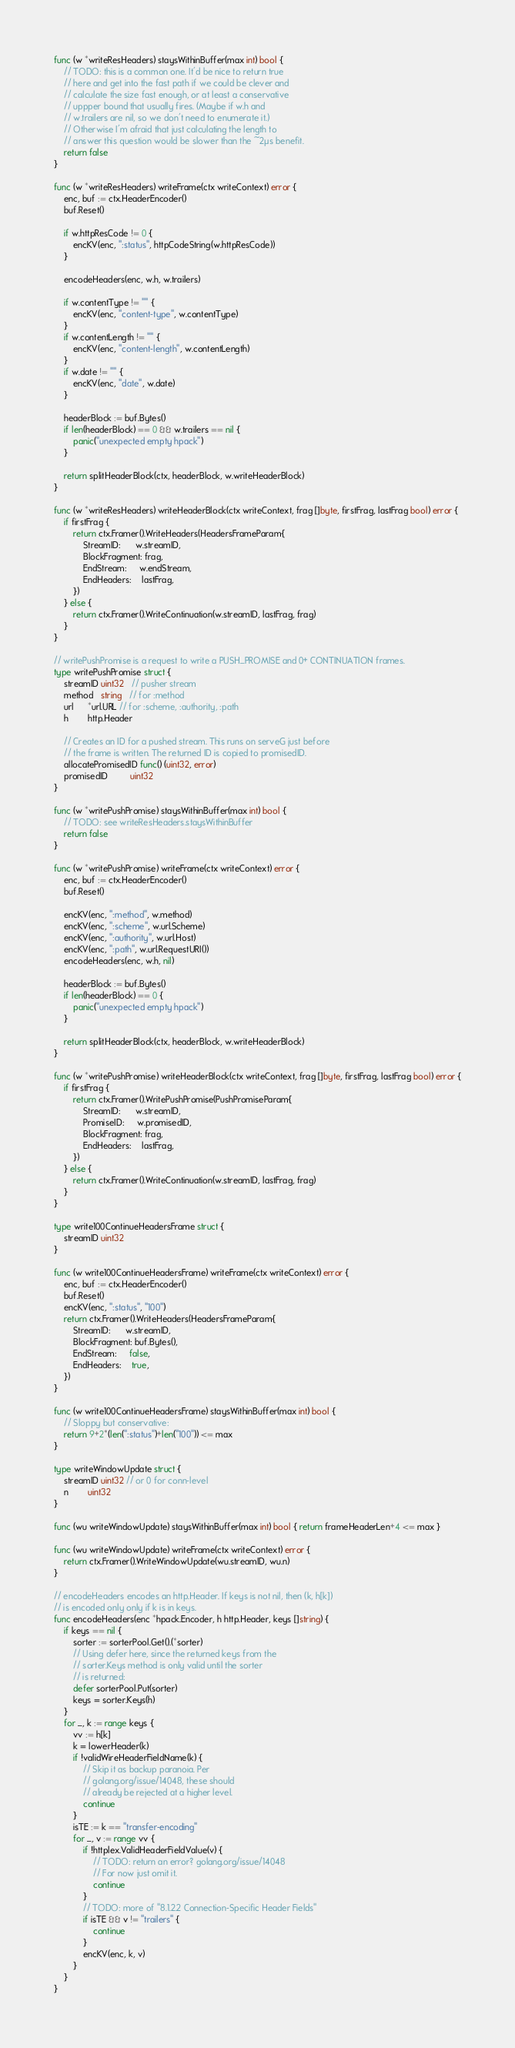<code> <loc_0><loc_0><loc_500><loc_500><_Go_>
func (w *writeResHeaders) staysWithinBuffer(max int) bool {
	// TODO: this is a common one. It'd be nice to return true
	// here and get into the fast path if we could be clever and
	// calculate the size fast enough, or at least a conservative
	// uppper bound that usually fires. (Maybe if w.h and
	// w.trailers are nil, so we don't need to enumerate it.)
	// Otherwise I'm afraid that just calculating the length to
	// answer this question would be slower than the ~2µs benefit.
	return false
}

func (w *writeResHeaders) writeFrame(ctx writeContext) error {
	enc, buf := ctx.HeaderEncoder()
	buf.Reset()

	if w.httpResCode != 0 {
		encKV(enc, ":status", httpCodeString(w.httpResCode))
	}

	encodeHeaders(enc, w.h, w.trailers)

	if w.contentType != "" {
		encKV(enc, "content-type", w.contentType)
	}
	if w.contentLength != "" {
		encKV(enc, "content-length", w.contentLength)
	}
	if w.date != "" {
		encKV(enc, "date", w.date)
	}

	headerBlock := buf.Bytes()
	if len(headerBlock) == 0 && w.trailers == nil {
		panic("unexpected empty hpack")
	}

	return splitHeaderBlock(ctx, headerBlock, w.writeHeaderBlock)
}

func (w *writeResHeaders) writeHeaderBlock(ctx writeContext, frag []byte, firstFrag, lastFrag bool) error {
	if firstFrag {
		return ctx.Framer().WriteHeaders(HeadersFrameParam{
			StreamID:      w.streamID,
			BlockFragment: frag,
			EndStream:     w.endStream,
			EndHeaders:    lastFrag,
		})
	} else {
		return ctx.Framer().WriteContinuation(w.streamID, lastFrag, frag)
	}
}

// writePushPromise is a request to write a PUSH_PROMISE and 0+ CONTINUATION frames.
type writePushPromise struct {
	streamID uint32   // pusher stream
	method   string   // for :method
	url      *url.URL // for :scheme, :authority, :path
	h        http.Header

	// Creates an ID for a pushed stream. This runs on serveG just before
	// the frame is written. The returned ID is copied to promisedID.
	allocatePromisedID func() (uint32, error)
	promisedID         uint32
}

func (w *writePushPromise) staysWithinBuffer(max int) bool {
	// TODO: see writeResHeaders.staysWithinBuffer
	return false
}

func (w *writePushPromise) writeFrame(ctx writeContext) error {
	enc, buf := ctx.HeaderEncoder()
	buf.Reset()

	encKV(enc, ":method", w.method)
	encKV(enc, ":scheme", w.url.Scheme)
	encKV(enc, ":authority", w.url.Host)
	encKV(enc, ":path", w.url.RequestURI())
	encodeHeaders(enc, w.h, nil)

	headerBlock := buf.Bytes()
	if len(headerBlock) == 0 {
		panic("unexpected empty hpack")
	}

	return splitHeaderBlock(ctx, headerBlock, w.writeHeaderBlock)
}

func (w *writePushPromise) writeHeaderBlock(ctx writeContext, frag []byte, firstFrag, lastFrag bool) error {
	if firstFrag {
		return ctx.Framer().WritePushPromise(PushPromiseParam{
			StreamID:      w.streamID,
			PromiseID:     w.promisedID,
			BlockFragment: frag,
			EndHeaders:    lastFrag,
		})
	} else {
		return ctx.Framer().WriteContinuation(w.streamID, lastFrag, frag)
	}
}

type write100ContinueHeadersFrame struct {
	streamID uint32
}

func (w write100ContinueHeadersFrame) writeFrame(ctx writeContext) error {
	enc, buf := ctx.HeaderEncoder()
	buf.Reset()
	encKV(enc, ":status", "100")
	return ctx.Framer().WriteHeaders(HeadersFrameParam{
		StreamID:      w.streamID,
		BlockFragment: buf.Bytes(),
		EndStream:     false,
		EndHeaders:    true,
	})
}

func (w write100ContinueHeadersFrame) staysWithinBuffer(max int) bool {
	// Sloppy but conservative:
	return 9+2*(len(":status")+len("100")) <= max
}

type writeWindowUpdate struct {
	streamID uint32 // or 0 for conn-level
	n        uint32
}

func (wu writeWindowUpdate) staysWithinBuffer(max int) bool { return frameHeaderLen+4 <= max }

func (wu writeWindowUpdate) writeFrame(ctx writeContext) error {
	return ctx.Framer().WriteWindowUpdate(wu.streamID, wu.n)
}

// encodeHeaders encodes an http.Header. If keys is not nil, then (k, h[k])
// is encoded only only if k is in keys.
func encodeHeaders(enc *hpack.Encoder, h http.Header, keys []string) {
	if keys == nil {
		sorter := sorterPool.Get().(*sorter)
		// Using defer here, since the returned keys from the
		// sorter.Keys method is only valid until the sorter
		// is returned:
		defer sorterPool.Put(sorter)
		keys = sorter.Keys(h)
	}
	for _, k := range keys {
		vv := h[k]
		k = lowerHeader(k)
		if !validWireHeaderFieldName(k) {
			// Skip it as backup paranoia. Per
			// golang.org/issue/14048, these should
			// already be rejected at a higher level.
			continue
		}
		isTE := k == "transfer-encoding"
		for _, v := range vv {
			if !httplex.ValidHeaderFieldValue(v) {
				// TODO: return an error? golang.org/issue/14048
				// For now just omit it.
				continue
			}
			// TODO: more of "8.1.2.2 Connection-Specific Header Fields"
			if isTE && v != "trailers" {
				continue
			}
			encKV(enc, k, v)
		}
	}
}
</code> 